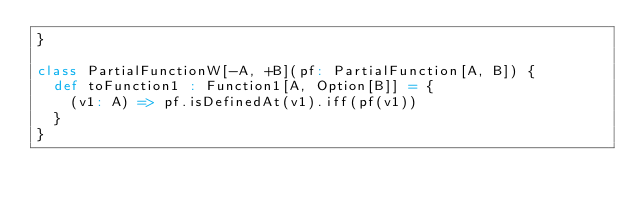<code> <loc_0><loc_0><loc_500><loc_500><_Scala_>}

class PartialFunctionW[-A, +B](pf: PartialFunction[A, B]) {
  def toFunction1 : Function1[A, Option[B]] = {
    (v1: A) => pf.isDefinedAt(v1).iff(pf(v1))
  }
}
</code> 